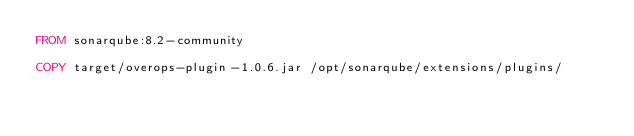<code> <loc_0><loc_0><loc_500><loc_500><_Dockerfile_>FROM sonarqube:8.2-community

COPY target/overops-plugin-1.0.6.jar /opt/sonarqube/extensions/plugins/
</code> 